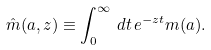Convert formula to latex. <formula><loc_0><loc_0><loc_500><loc_500>\hat { m } ( a , z ) \equiv \int _ { 0 } ^ { \infty } \, d t \, e ^ { - z t } m ( a ) .</formula> 